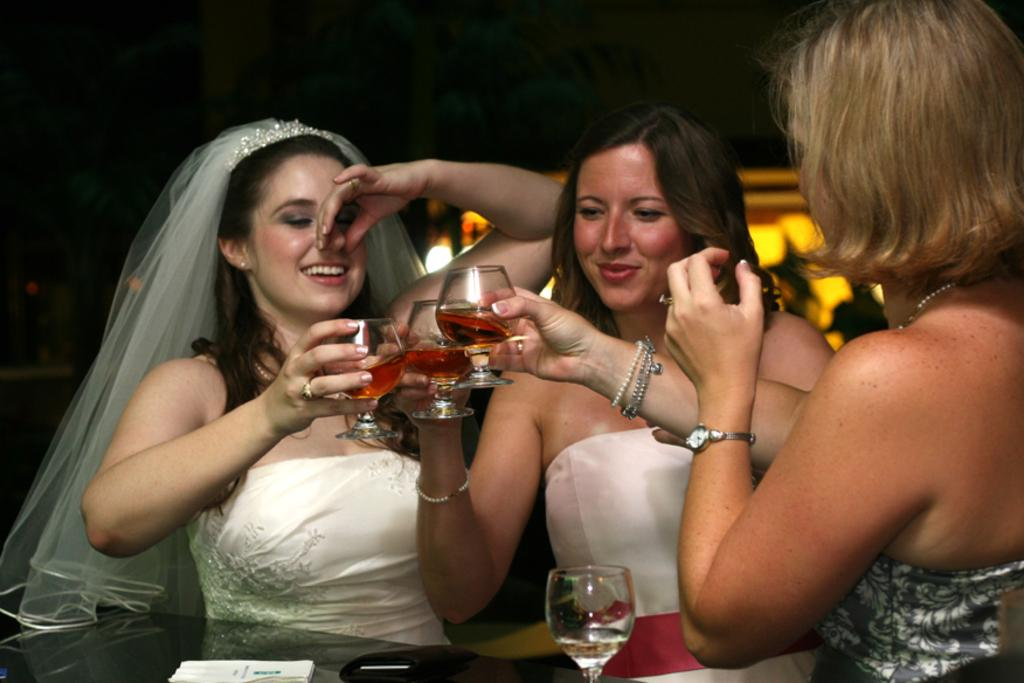How many women are in the image? There are three women in the image. What are the women holding in their hands? The women are holding glasses with liquid. What is the facial expression of the women? The women are smiling. What is located in front of one of the women? There is a table in front of one of the women. What items can be seen on the table? There is a wallet, a book, and a glass of water on the table. What type of metal object is the dad holding in the image? There is no dad or metal object present in the image. 